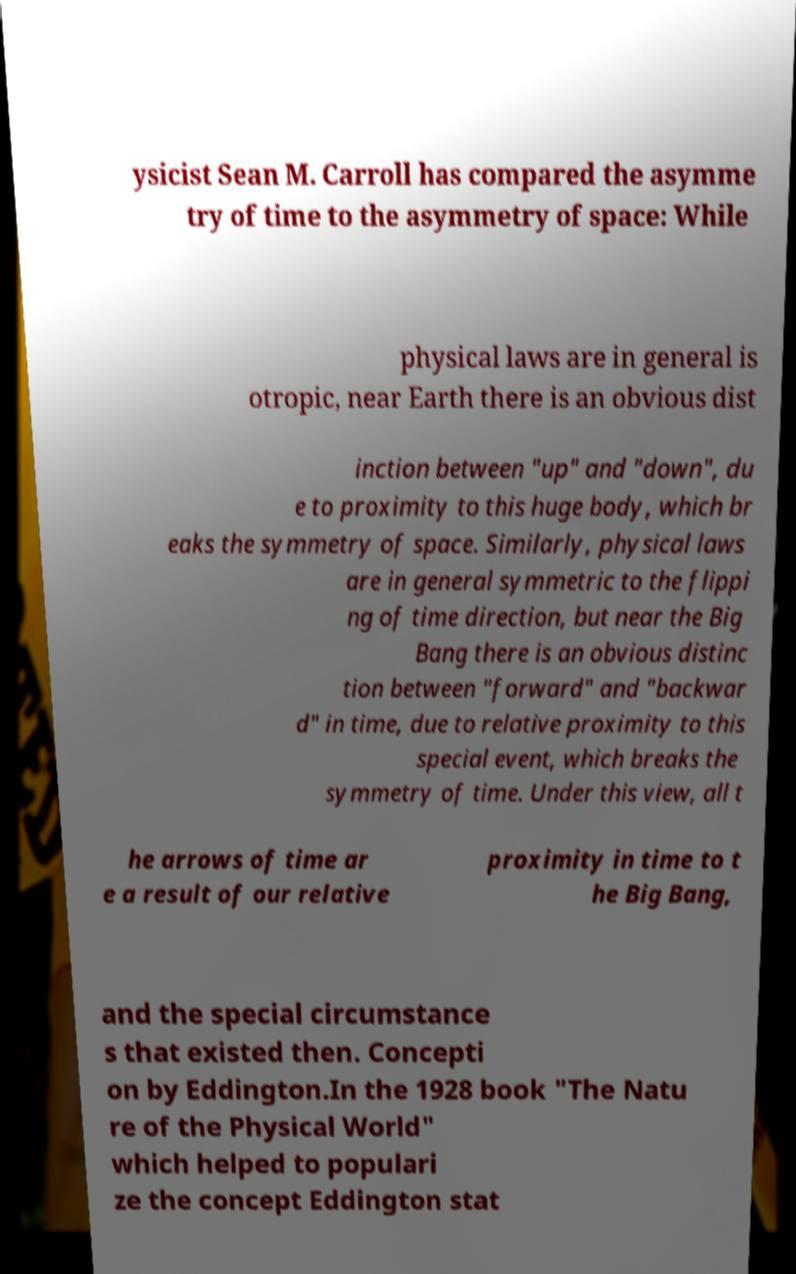Could you extract and type out the text from this image? ysicist Sean M. Carroll has compared the asymme try of time to the asymmetry of space: While physical laws are in general is otropic, near Earth there is an obvious dist inction between "up" and "down", du e to proximity to this huge body, which br eaks the symmetry of space. Similarly, physical laws are in general symmetric to the flippi ng of time direction, but near the Big Bang there is an obvious distinc tion between "forward" and "backwar d" in time, due to relative proximity to this special event, which breaks the symmetry of time. Under this view, all t he arrows of time ar e a result of our relative proximity in time to t he Big Bang, and the special circumstance s that existed then. Concepti on by Eddington.In the 1928 book "The Natu re of the Physical World" which helped to populari ze the concept Eddington stat 